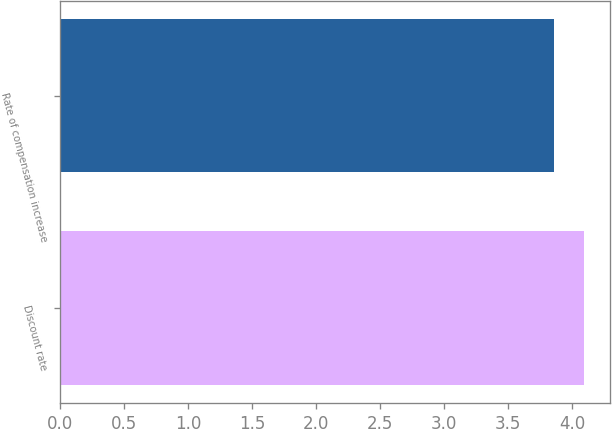<chart> <loc_0><loc_0><loc_500><loc_500><bar_chart><fcel>Discount rate<fcel>Rate of compensation increase<nl><fcel>4.09<fcel>3.86<nl></chart> 